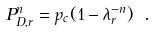Convert formula to latex. <formula><loc_0><loc_0><loc_500><loc_500>P _ { D , r } ^ { n } = p _ { c } ( 1 - \lambda _ { r } ^ { - n } ) \ .</formula> 